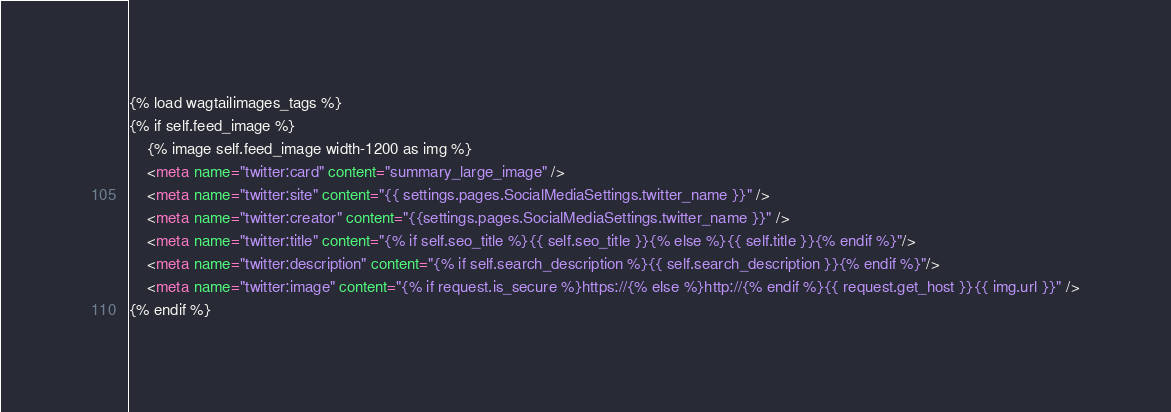Convert code to text. <code><loc_0><loc_0><loc_500><loc_500><_HTML_>{% load wagtailimages_tags %}
{% if self.feed_image %}
    {% image self.feed_image width-1200 as img %}
    <meta name="twitter:card" content="summary_large_image" />
    <meta name="twitter:site" content="{{ settings.pages.SocialMediaSettings.twitter_name }}" />
    <meta name="twitter:creator" content="{{settings.pages.SocialMediaSettings.twitter_name }}" />
    <meta name="twitter:title" content="{% if self.seo_title %}{{ self.seo_title }}{% else %}{{ self.title }}{% endif %}"/>
    <meta name="twitter:description" content="{% if self.search_description %}{{ self.search_description }}{% endif %}"/>
    <meta name="twitter:image" content="{% if request.is_secure %}https://{% else %}http://{% endif %}{{ request.get_host }}{{ img.url }}" />
{% endif %}</code> 